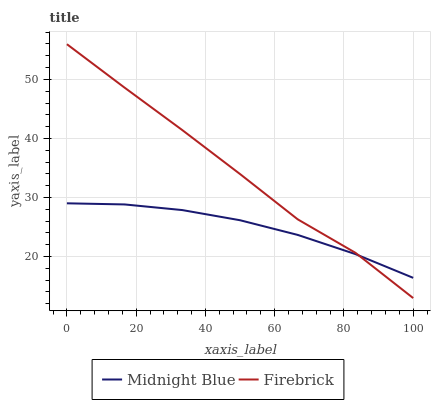Does Midnight Blue have the maximum area under the curve?
Answer yes or no. No. Is Midnight Blue the roughest?
Answer yes or no. No. Does Midnight Blue have the lowest value?
Answer yes or no. No. Does Midnight Blue have the highest value?
Answer yes or no. No. 